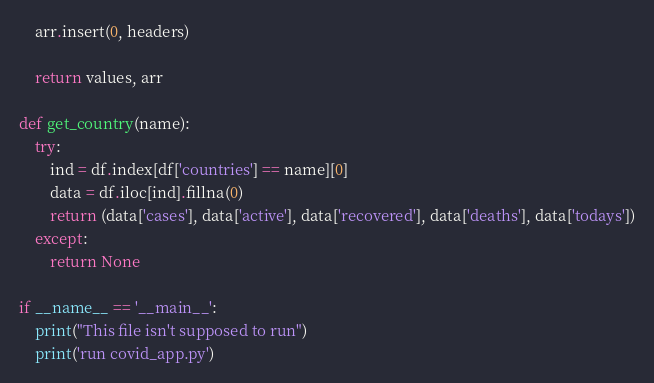Convert code to text. <code><loc_0><loc_0><loc_500><loc_500><_Python_>	arr.insert(0, headers)

	return values, arr

def get_country(name):
	try:
		ind = df.index[df['countries'] == name][0]
		data = df.iloc[ind].fillna(0)
		return (data['cases'], data['active'], data['recovered'], data['deaths'], data['todays'])
	except:
		return None

if __name__ == '__main__':
	print("This file isn't supposed to run")
	print('run covid_app.py')</code> 